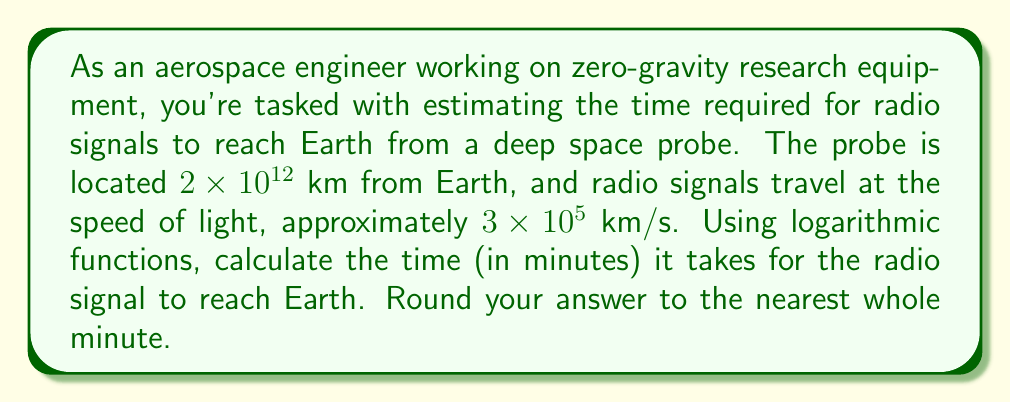Teach me how to tackle this problem. To solve this problem, we'll use the basic formula for time:

$$t = \frac{d}{v}$$

Where:
$t$ = time
$d$ = distance
$v$ = velocity

Given:
$d = 2 \times 10^{12}$ km
$v = 3 \times 10^5$ km/s

Step 1: Substitute the values into the formula:

$$t = \frac{2 \times 10^{12}}{3 \times 10^5}$$

Step 2: Simplify the fraction:

$$t = \frac{2}{3} \times 10^7 \text{ seconds}$$

Step 3: Convert seconds to minutes by dividing by 60:

$$t = \frac{2}{3} \times 10^7 \times \frac{1}{60} \text{ minutes}$$

Step 4: Simplify:

$$t = \frac{1}{3} \times \frac{10^7}{60} \text{ minutes}$$

Step 5: To simplify this further, we can use logarithms. Let's take $\log_{10}$ of both sides:

$$\log_{10}(t) = \log_{10}\left(\frac{1}{3} \times \frac{10^7}{60}\right)$$

Step 6: Use the logarithm product rule:

$$\log_{10}(t) = \log_{10}\left(\frac{1}{3}\right) + \log_{10}\left(\frac{10^7}{60}\right)$$

Step 7: Simplify:

$$\log_{10}(t) = -\log_{10}(3) + 7 - \log_{10}(60)$$

Step 8: Calculate:

$$\log_{10}(t) \approx -0.4771 + 7 - 1.7782 \approx 4.7447$$

Step 9: Take $10$ to the power of both sides:

$$t \approx 10^{4.7447} \approx 55555.56 \text{ minutes}$$

Step 10: Round to the nearest whole minute:

$$t \approx 55556 \text{ minutes}$$
Answer: The radio signal will take approximately 55556 minutes to reach Earth from the deep space probe. 